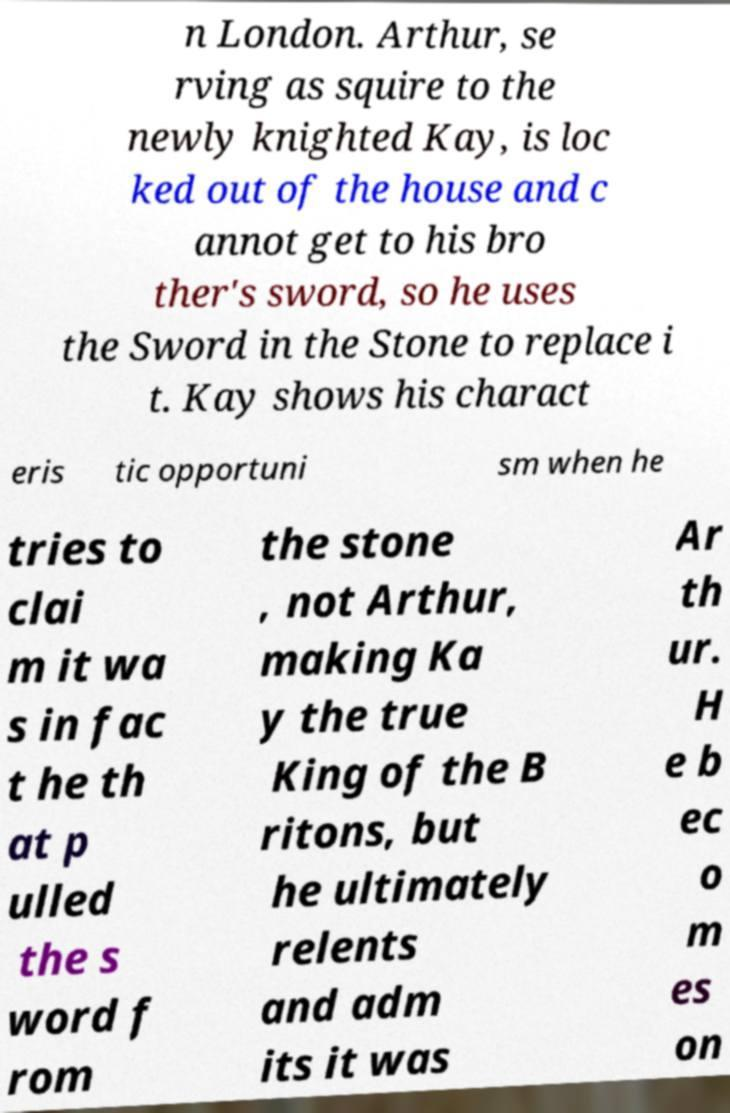Can you accurately transcribe the text from the provided image for me? n London. Arthur, se rving as squire to the newly knighted Kay, is loc ked out of the house and c annot get to his bro ther's sword, so he uses the Sword in the Stone to replace i t. Kay shows his charact eris tic opportuni sm when he tries to clai m it wa s in fac t he th at p ulled the s word f rom the stone , not Arthur, making Ka y the true King of the B ritons, but he ultimately relents and adm its it was Ar th ur. H e b ec o m es on 